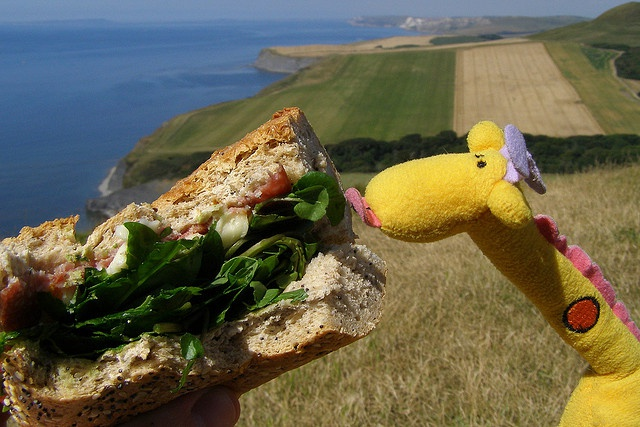Describe the objects in this image and their specific colors. I can see sandwich in gray, black, olive, maroon, and tan tones and people in gray, black, and maroon tones in this image. 